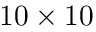Convert formula to latex. <formula><loc_0><loc_0><loc_500><loc_500>1 0 \times 1 0</formula> 